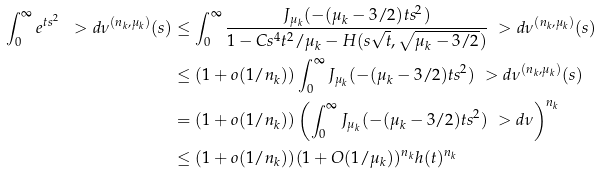Convert formula to latex. <formula><loc_0><loc_0><loc_500><loc_500>\int _ { 0 } ^ { \infty } e ^ { t s ^ { 2 } } \ > d \nu ^ { ( n _ { k } , \mu _ { k } ) } ( s ) & \leq \int _ { 0 } ^ { \infty } \frac { J _ { \mu _ { k } } ( - ( \mu _ { k } - 3 / 2 ) t s ^ { 2 } ) } { 1 - C s ^ { 4 } t ^ { 2 } / \mu _ { k } - H ( s \sqrt { t } , \sqrt { \mu _ { k } - 3 / 2 } ) } \ > d \nu ^ { ( n _ { k } , \mu _ { k } ) } ( s ) \\ & \leq ( 1 + o ( 1 / n _ { k } ) ) \int _ { 0 } ^ { \infty } J _ { \mu _ { k } } ( - ( \mu _ { k } - 3 / 2 ) t s ^ { 2 } ) \ > d \nu ^ { ( n _ { k } , \mu _ { k } ) } ( s ) \\ & = ( 1 + o ( 1 / n _ { k } ) ) \left ( \int _ { 0 } ^ { \infty } J _ { \mu _ { k } } ( - ( \mu _ { k } - 3 / 2 ) t s ^ { 2 } ) \ > d \nu \right ) ^ { n _ { k } } \\ & \leq ( 1 + o ( 1 / n _ { k } ) ) ( 1 + O ( 1 / \mu _ { k } ) ) ^ { n _ { k } } h ( t ) ^ { n _ { k } }</formula> 